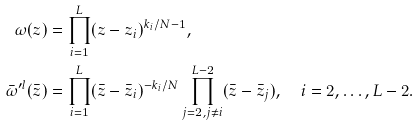<formula> <loc_0><loc_0><loc_500><loc_500>\omega ( z ) & = \prod _ { i = 1 } ^ { L } ( z - z _ { i } ) ^ { k _ { i } / N - 1 } , \\ \bar { \omega } ^ { \prime l } ( \bar { z } ) & = \prod _ { i = 1 } ^ { L } ( \bar { z } - \bar { z } _ { i } ) ^ { - k _ { i } / N } \prod _ { j = 2 , j \ne i } ^ { L - 2 } ( \bar { z } - \bar { z } _ { j } ) , \quad i = 2 , \dots , L - 2 .</formula> 